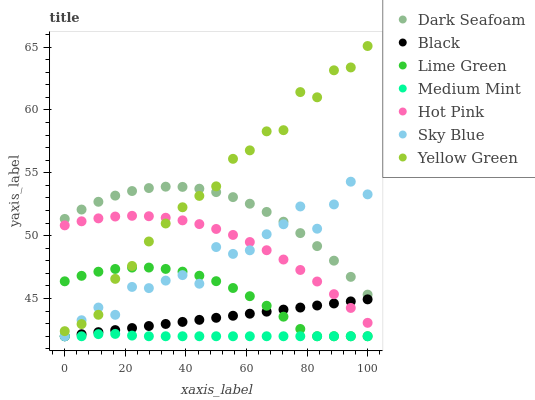Does Medium Mint have the minimum area under the curve?
Answer yes or no. Yes. Does Yellow Green have the maximum area under the curve?
Answer yes or no. Yes. Does Hot Pink have the minimum area under the curve?
Answer yes or no. No. Does Hot Pink have the maximum area under the curve?
Answer yes or no. No. Is Black the smoothest?
Answer yes or no. Yes. Is Sky Blue the roughest?
Answer yes or no. Yes. Is Yellow Green the smoothest?
Answer yes or no. No. Is Yellow Green the roughest?
Answer yes or no. No. Does Medium Mint have the lowest value?
Answer yes or no. Yes. Does Yellow Green have the lowest value?
Answer yes or no. No. Does Yellow Green have the highest value?
Answer yes or no. Yes. Does Hot Pink have the highest value?
Answer yes or no. No. Is Black less than Yellow Green?
Answer yes or no. Yes. Is Hot Pink greater than Medium Mint?
Answer yes or no. Yes. Does Black intersect Medium Mint?
Answer yes or no. Yes. Is Black less than Medium Mint?
Answer yes or no. No. Is Black greater than Medium Mint?
Answer yes or no. No. Does Black intersect Yellow Green?
Answer yes or no. No. 